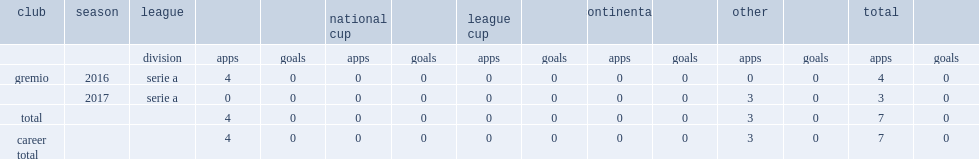Which club did tyroane play for in 2016? Gremio. 